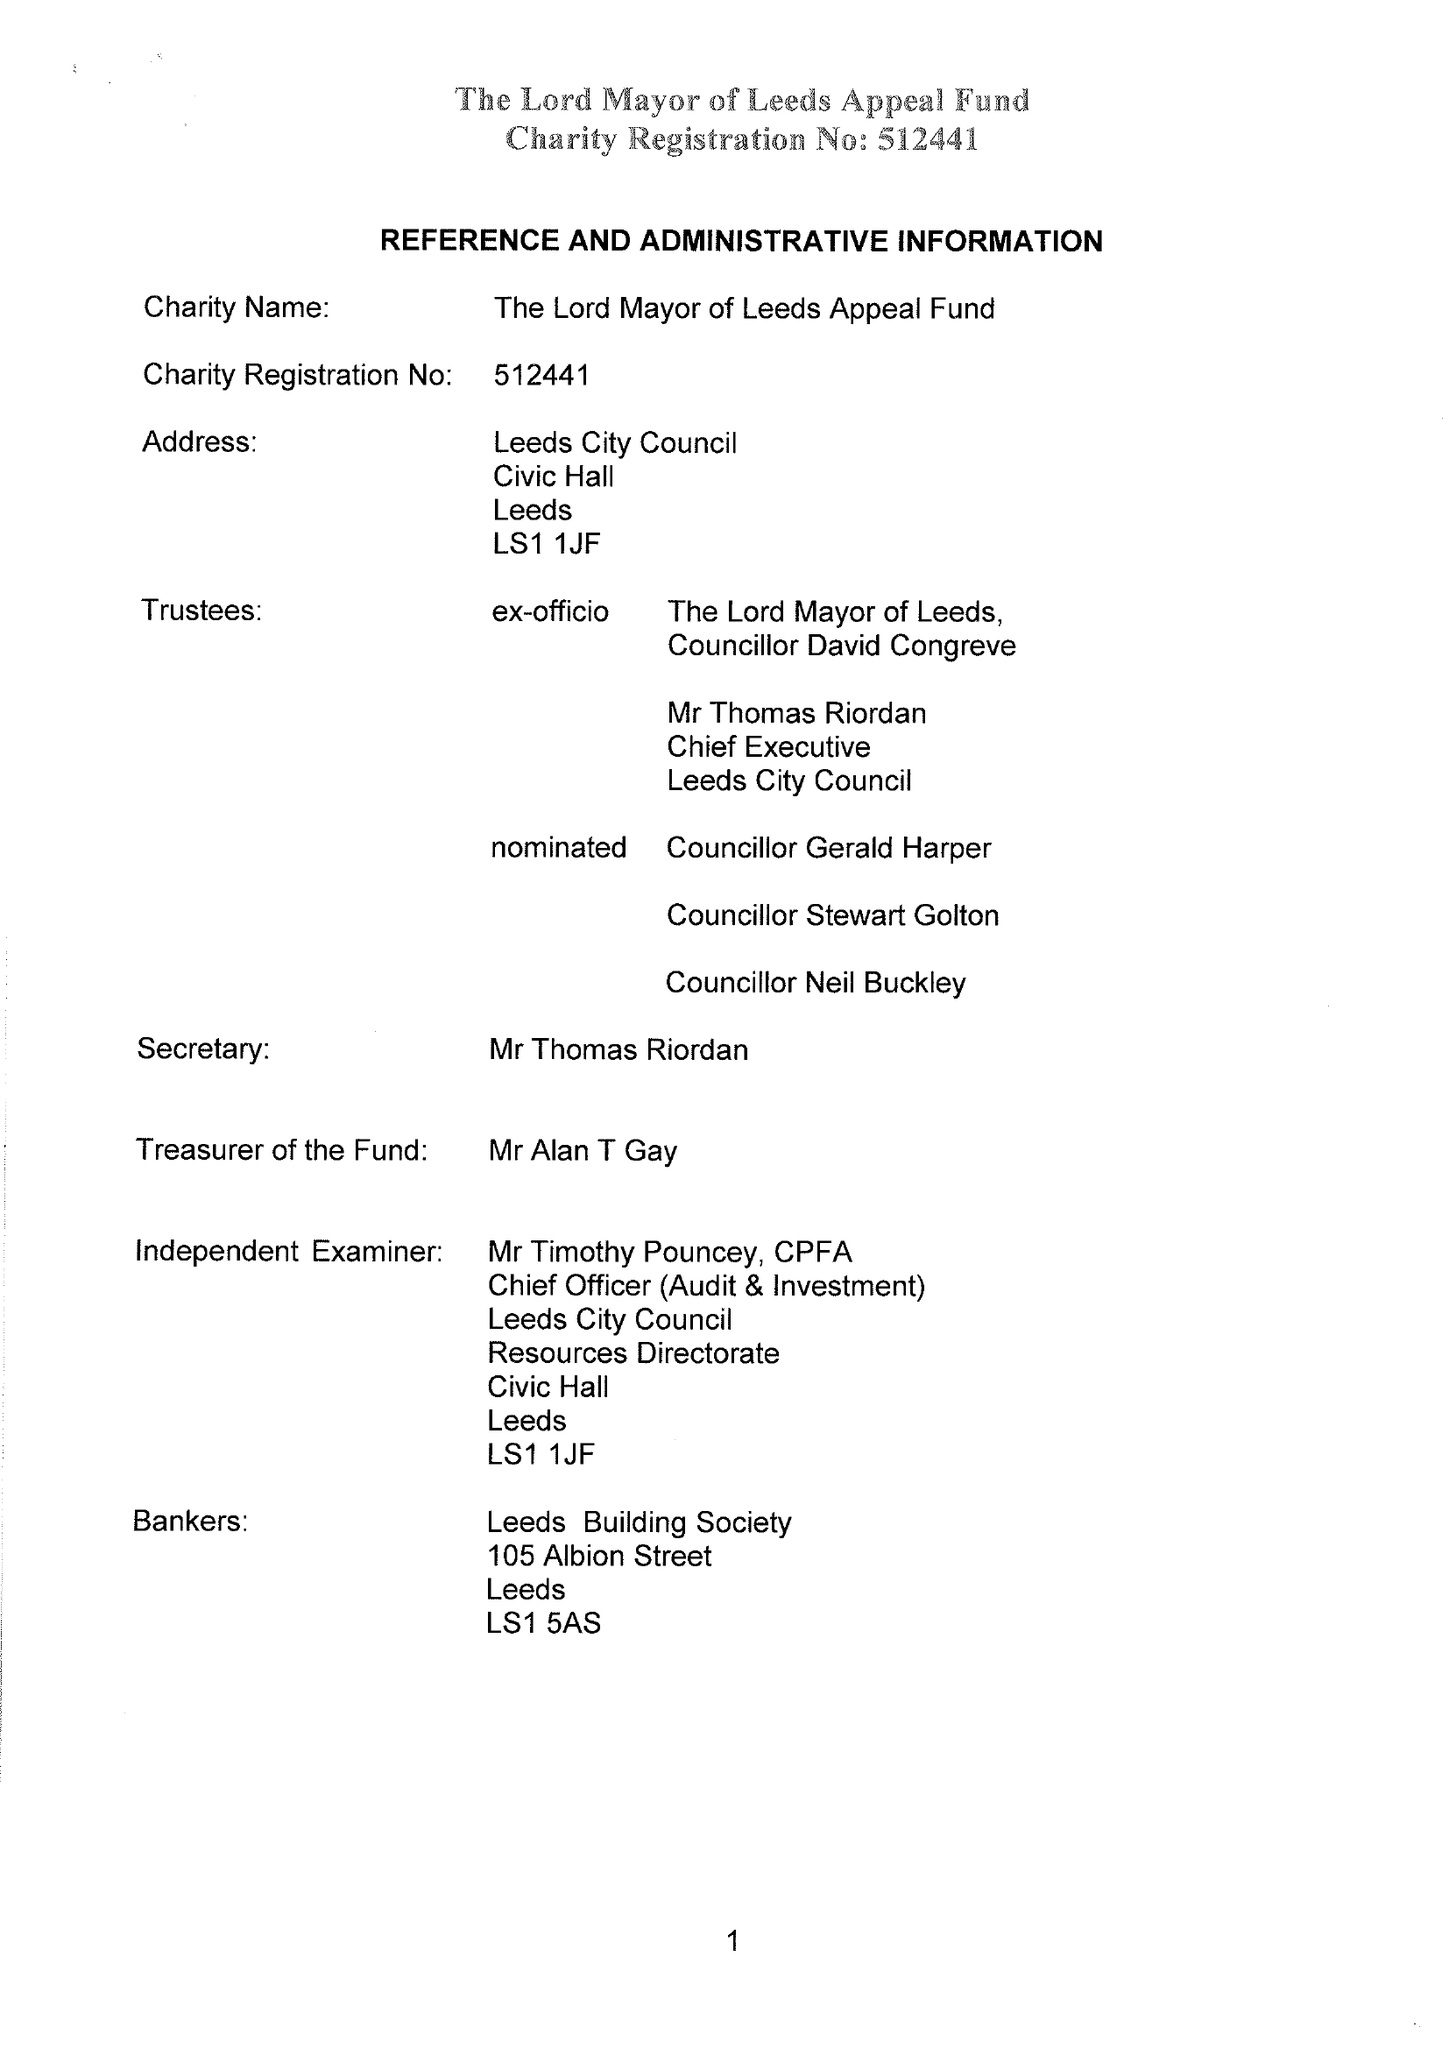What is the value for the address__street_line?
Answer the question using a single word or phrase. None 